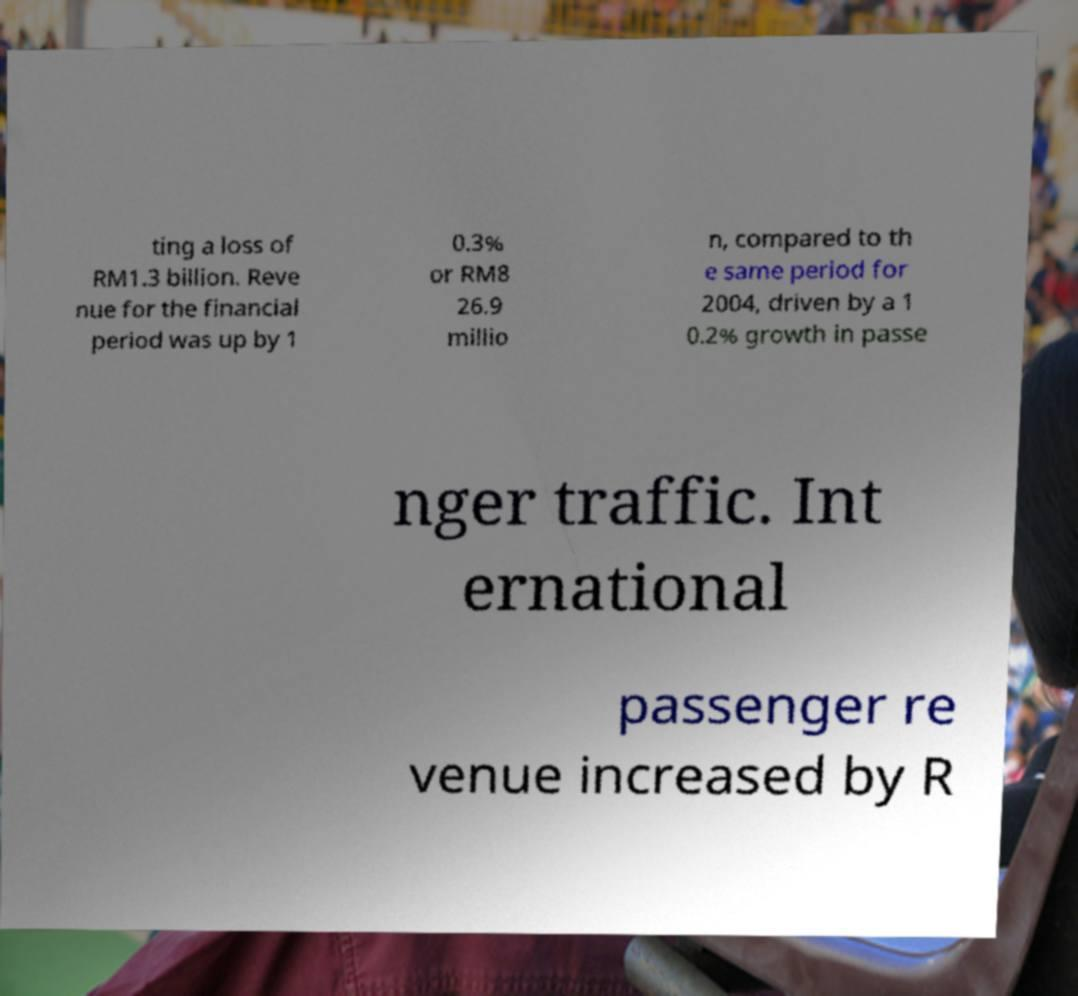What messages or text are displayed in this image? I need them in a readable, typed format. ting a loss of RM1.3 billion. Reve nue for the financial period was up by 1 0.3% or RM8 26.9 millio n, compared to th e same period for 2004, driven by a 1 0.2% growth in passe nger traffic. Int ernational passenger re venue increased by R 